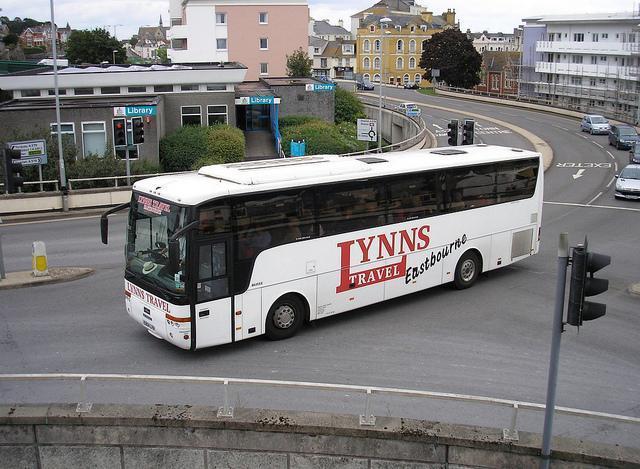How many street lights are there?
Give a very brief answer. 2. 